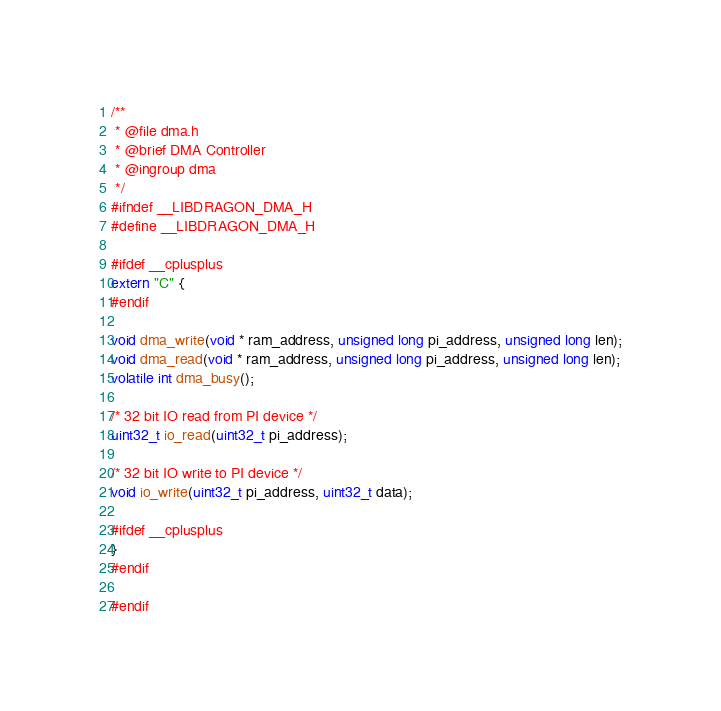<code> <loc_0><loc_0><loc_500><loc_500><_C_>/**
 * @file dma.h
 * @brief DMA Controller
 * @ingroup dma
 */
#ifndef __LIBDRAGON_DMA_H
#define __LIBDRAGON_DMA_H

#ifdef __cplusplus
extern "C" {
#endif

void dma_write(void * ram_address, unsigned long pi_address, unsigned long len);
void dma_read(void * ram_address, unsigned long pi_address, unsigned long len);
volatile int dma_busy();

/* 32 bit IO read from PI device */
uint32_t io_read(uint32_t pi_address);

/* 32 bit IO write to PI device */
void io_write(uint32_t pi_address, uint32_t data);

#ifdef __cplusplus
}
#endif

#endif
</code> 